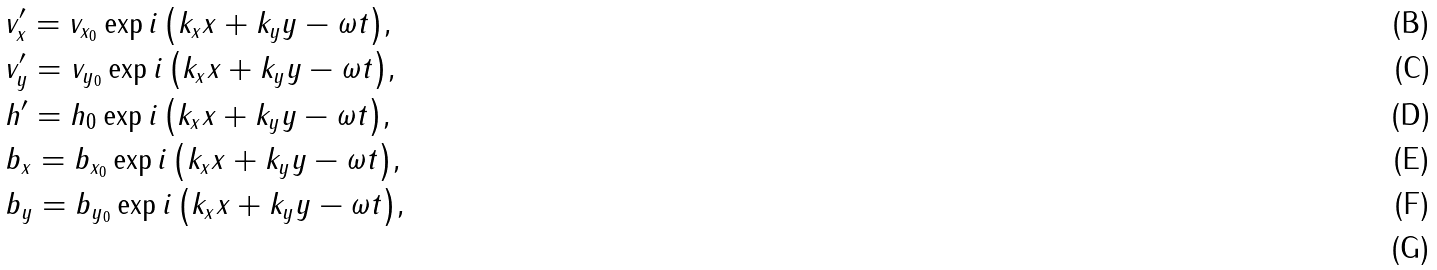Convert formula to latex. <formula><loc_0><loc_0><loc_500><loc_500>& v ^ { \prime } _ { x } = v _ { x _ { 0 } } \exp { i \left ( k _ { x } x + k _ { y } y - \omega t \right ) } , \\ & v ^ { \prime } _ { y } = v _ { y _ { 0 } } \exp { i \left ( k _ { x } x + k _ { y } y - \omega t \right ) } , \\ & h ^ { \prime } = h _ { 0 } \exp { i \left ( k _ { x } x + k _ { y } y - \omega t \right ) } , \\ & b _ { x } = b _ { x _ { 0 } } \exp { i \left ( k _ { x } x + k _ { y } y - \omega t \right ) } , \\ & b _ { y } = b _ { y _ { 0 } } \exp { i \left ( k _ { x } x + k _ { y } y - \omega t \right ) } , \\</formula> 